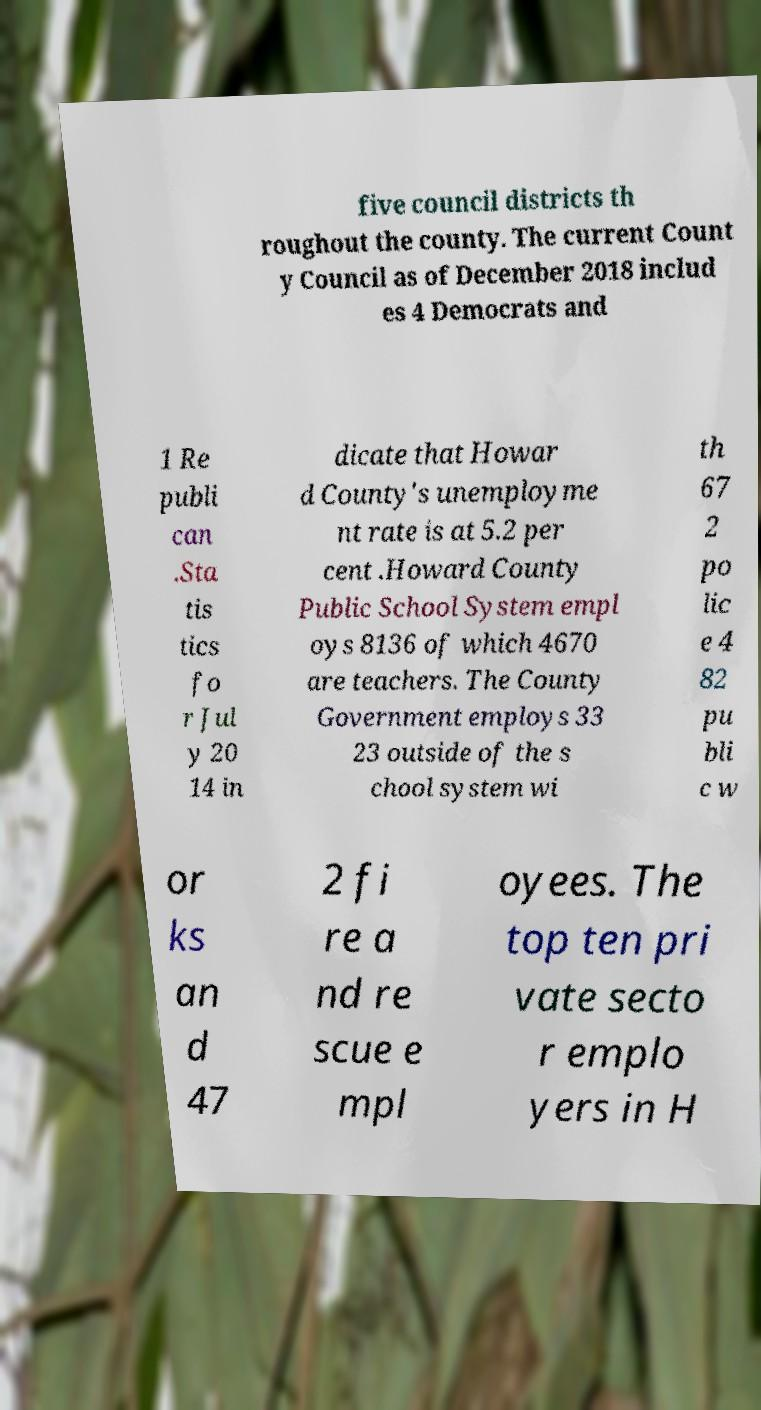Please read and relay the text visible in this image. What does it say? five council districts th roughout the county. The current Count y Council as of December 2018 includ es 4 Democrats and 1 Re publi can .Sta tis tics fo r Jul y 20 14 in dicate that Howar d County's unemployme nt rate is at 5.2 per cent .Howard County Public School System empl oys 8136 of which 4670 are teachers. The County Government employs 33 23 outside of the s chool system wi th 67 2 po lic e 4 82 pu bli c w or ks an d 47 2 fi re a nd re scue e mpl oyees. The top ten pri vate secto r emplo yers in H 